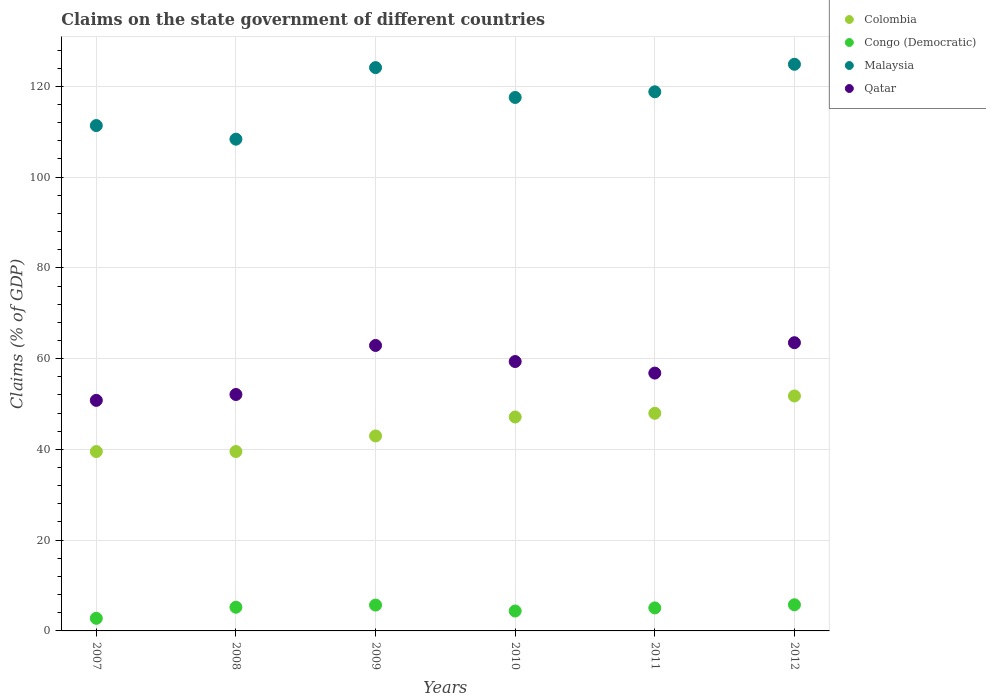Is the number of dotlines equal to the number of legend labels?
Offer a very short reply. Yes. What is the percentage of GDP claimed on the state government in Qatar in 2012?
Provide a short and direct response. 63.51. Across all years, what is the maximum percentage of GDP claimed on the state government in Congo (Democratic)?
Offer a very short reply. 5.76. Across all years, what is the minimum percentage of GDP claimed on the state government in Malaysia?
Offer a terse response. 108.35. What is the total percentage of GDP claimed on the state government in Congo (Democratic) in the graph?
Keep it short and to the point. 28.92. What is the difference between the percentage of GDP claimed on the state government in Qatar in 2008 and that in 2010?
Offer a very short reply. -7.26. What is the difference between the percentage of GDP claimed on the state government in Congo (Democratic) in 2010 and the percentage of GDP claimed on the state government in Malaysia in 2007?
Offer a very short reply. -106.96. What is the average percentage of GDP claimed on the state government in Malaysia per year?
Your response must be concise. 117.5. In the year 2010, what is the difference between the percentage of GDP claimed on the state government in Congo (Democratic) and percentage of GDP claimed on the state government in Malaysia?
Your answer should be very brief. -113.15. In how many years, is the percentage of GDP claimed on the state government in Qatar greater than 56 %?
Keep it short and to the point. 4. What is the ratio of the percentage of GDP claimed on the state government in Congo (Democratic) in 2010 to that in 2012?
Give a very brief answer. 0.76. Is the percentage of GDP claimed on the state government in Malaysia in 2007 less than that in 2010?
Ensure brevity in your answer.  Yes. Is the difference between the percentage of GDP claimed on the state government in Congo (Democratic) in 2007 and 2010 greater than the difference between the percentage of GDP claimed on the state government in Malaysia in 2007 and 2010?
Your response must be concise. Yes. What is the difference between the highest and the second highest percentage of GDP claimed on the state government in Qatar?
Your answer should be compact. 0.61. What is the difference between the highest and the lowest percentage of GDP claimed on the state government in Colombia?
Keep it short and to the point. 12.25. In how many years, is the percentage of GDP claimed on the state government in Qatar greater than the average percentage of GDP claimed on the state government in Qatar taken over all years?
Keep it short and to the point. 3. Is the sum of the percentage of GDP claimed on the state government in Congo (Democratic) in 2010 and 2012 greater than the maximum percentage of GDP claimed on the state government in Malaysia across all years?
Your response must be concise. No. Is it the case that in every year, the sum of the percentage of GDP claimed on the state government in Malaysia and percentage of GDP claimed on the state government in Colombia  is greater than the sum of percentage of GDP claimed on the state government in Congo (Democratic) and percentage of GDP claimed on the state government in Qatar?
Keep it short and to the point. No. Does the percentage of GDP claimed on the state government in Qatar monotonically increase over the years?
Your response must be concise. No. How many years are there in the graph?
Your response must be concise. 6. Are the values on the major ticks of Y-axis written in scientific E-notation?
Offer a terse response. No. Does the graph contain any zero values?
Give a very brief answer. No. Does the graph contain grids?
Provide a succinct answer. Yes. Where does the legend appear in the graph?
Your answer should be very brief. Top right. What is the title of the graph?
Provide a short and direct response. Claims on the state government of different countries. Does "Italy" appear as one of the legend labels in the graph?
Provide a succinct answer. No. What is the label or title of the Y-axis?
Your answer should be very brief. Claims (% of GDP). What is the Claims (% of GDP) in Colombia in 2007?
Offer a terse response. 39.53. What is the Claims (% of GDP) in Congo (Democratic) in 2007?
Your response must be concise. 2.78. What is the Claims (% of GDP) of Malaysia in 2007?
Give a very brief answer. 111.35. What is the Claims (% of GDP) in Qatar in 2007?
Keep it short and to the point. 50.8. What is the Claims (% of GDP) in Colombia in 2008?
Make the answer very short. 39.53. What is the Claims (% of GDP) of Congo (Democratic) in 2008?
Make the answer very short. 5.22. What is the Claims (% of GDP) in Malaysia in 2008?
Give a very brief answer. 108.35. What is the Claims (% of GDP) in Qatar in 2008?
Your answer should be very brief. 52.09. What is the Claims (% of GDP) in Colombia in 2009?
Provide a succinct answer. 42.96. What is the Claims (% of GDP) in Congo (Democratic) in 2009?
Your answer should be compact. 5.7. What is the Claims (% of GDP) of Malaysia in 2009?
Make the answer very short. 124.12. What is the Claims (% of GDP) in Qatar in 2009?
Provide a succinct answer. 62.9. What is the Claims (% of GDP) of Colombia in 2010?
Offer a very short reply. 47.14. What is the Claims (% of GDP) of Congo (Democratic) in 2010?
Your answer should be compact. 4.39. What is the Claims (% of GDP) in Malaysia in 2010?
Your answer should be very brief. 117.54. What is the Claims (% of GDP) of Qatar in 2010?
Offer a very short reply. 59.36. What is the Claims (% of GDP) of Colombia in 2011?
Your answer should be very brief. 47.96. What is the Claims (% of GDP) in Congo (Democratic) in 2011?
Provide a succinct answer. 5.07. What is the Claims (% of GDP) in Malaysia in 2011?
Give a very brief answer. 118.79. What is the Claims (% of GDP) of Qatar in 2011?
Your answer should be very brief. 56.81. What is the Claims (% of GDP) of Colombia in 2012?
Ensure brevity in your answer.  51.77. What is the Claims (% of GDP) in Congo (Democratic) in 2012?
Provide a succinct answer. 5.76. What is the Claims (% of GDP) of Malaysia in 2012?
Keep it short and to the point. 124.86. What is the Claims (% of GDP) in Qatar in 2012?
Provide a succinct answer. 63.51. Across all years, what is the maximum Claims (% of GDP) of Colombia?
Offer a very short reply. 51.77. Across all years, what is the maximum Claims (% of GDP) of Congo (Democratic)?
Ensure brevity in your answer.  5.76. Across all years, what is the maximum Claims (% of GDP) in Malaysia?
Offer a very short reply. 124.86. Across all years, what is the maximum Claims (% of GDP) of Qatar?
Offer a terse response. 63.51. Across all years, what is the minimum Claims (% of GDP) in Colombia?
Offer a terse response. 39.53. Across all years, what is the minimum Claims (% of GDP) of Congo (Democratic)?
Your answer should be very brief. 2.78. Across all years, what is the minimum Claims (% of GDP) in Malaysia?
Make the answer very short. 108.35. Across all years, what is the minimum Claims (% of GDP) in Qatar?
Make the answer very short. 50.8. What is the total Claims (% of GDP) of Colombia in the graph?
Provide a short and direct response. 268.89. What is the total Claims (% of GDP) of Congo (Democratic) in the graph?
Keep it short and to the point. 28.92. What is the total Claims (% of GDP) in Malaysia in the graph?
Give a very brief answer. 705.02. What is the total Claims (% of GDP) in Qatar in the graph?
Your answer should be very brief. 345.47. What is the difference between the Claims (% of GDP) of Colombia in 2007 and that in 2008?
Your response must be concise. -0.01. What is the difference between the Claims (% of GDP) in Congo (Democratic) in 2007 and that in 2008?
Your response must be concise. -2.44. What is the difference between the Claims (% of GDP) in Malaysia in 2007 and that in 2008?
Give a very brief answer. 3. What is the difference between the Claims (% of GDP) of Qatar in 2007 and that in 2008?
Offer a terse response. -1.3. What is the difference between the Claims (% of GDP) of Colombia in 2007 and that in 2009?
Your response must be concise. -3.44. What is the difference between the Claims (% of GDP) in Congo (Democratic) in 2007 and that in 2009?
Give a very brief answer. -2.92. What is the difference between the Claims (% of GDP) in Malaysia in 2007 and that in 2009?
Your response must be concise. -12.77. What is the difference between the Claims (% of GDP) of Qatar in 2007 and that in 2009?
Provide a short and direct response. -12.1. What is the difference between the Claims (% of GDP) in Colombia in 2007 and that in 2010?
Provide a short and direct response. -7.62. What is the difference between the Claims (% of GDP) in Congo (Democratic) in 2007 and that in 2010?
Provide a short and direct response. -1.61. What is the difference between the Claims (% of GDP) in Malaysia in 2007 and that in 2010?
Keep it short and to the point. -6.19. What is the difference between the Claims (% of GDP) of Qatar in 2007 and that in 2010?
Your answer should be compact. -8.56. What is the difference between the Claims (% of GDP) in Colombia in 2007 and that in 2011?
Keep it short and to the point. -8.43. What is the difference between the Claims (% of GDP) of Congo (Democratic) in 2007 and that in 2011?
Offer a very short reply. -2.3. What is the difference between the Claims (% of GDP) in Malaysia in 2007 and that in 2011?
Provide a succinct answer. -7.44. What is the difference between the Claims (% of GDP) in Qatar in 2007 and that in 2011?
Provide a short and direct response. -6.01. What is the difference between the Claims (% of GDP) in Colombia in 2007 and that in 2012?
Keep it short and to the point. -12.25. What is the difference between the Claims (% of GDP) in Congo (Democratic) in 2007 and that in 2012?
Make the answer very short. -2.99. What is the difference between the Claims (% of GDP) in Malaysia in 2007 and that in 2012?
Offer a very short reply. -13.5. What is the difference between the Claims (% of GDP) of Qatar in 2007 and that in 2012?
Your answer should be very brief. -12.71. What is the difference between the Claims (% of GDP) of Colombia in 2008 and that in 2009?
Your answer should be very brief. -3.43. What is the difference between the Claims (% of GDP) of Congo (Democratic) in 2008 and that in 2009?
Give a very brief answer. -0.48. What is the difference between the Claims (% of GDP) in Malaysia in 2008 and that in 2009?
Your answer should be very brief. -15.77. What is the difference between the Claims (% of GDP) of Qatar in 2008 and that in 2009?
Give a very brief answer. -10.81. What is the difference between the Claims (% of GDP) in Colombia in 2008 and that in 2010?
Provide a succinct answer. -7.61. What is the difference between the Claims (% of GDP) of Congo (Democratic) in 2008 and that in 2010?
Keep it short and to the point. 0.83. What is the difference between the Claims (% of GDP) in Malaysia in 2008 and that in 2010?
Provide a succinct answer. -9.19. What is the difference between the Claims (% of GDP) in Qatar in 2008 and that in 2010?
Offer a terse response. -7.26. What is the difference between the Claims (% of GDP) in Colombia in 2008 and that in 2011?
Give a very brief answer. -8.42. What is the difference between the Claims (% of GDP) in Congo (Democratic) in 2008 and that in 2011?
Offer a very short reply. 0.15. What is the difference between the Claims (% of GDP) in Malaysia in 2008 and that in 2011?
Your response must be concise. -10.44. What is the difference between the Claims (% of GDP) of Qatar in 2008 and that in 2011?
Ensure brevity in your answer.  -4.72. What is the difference between the Claims (% of GDP) of Colombia in 2008 and that in 2012?
Give a very brief answer. -12.24. What is the difference between the Claims (% of GDP) in Congo (Democratic) in 2008 and that in 2012?
Offer a terse response. -0.55. What is the difference between the Claims (% of GDP) in Malaysia in 2008 and that in 2012?
Your answer should be compact. -16.5. What is the difference between the Claims (% of GDP) of Qatar in 2008 and that in 2012?
Offer a very short reply. -11.41. What is the difference between the Claims (% of GDP) of Colombia in 2009 and that in 2010?
Give a very brief answer. -4.18. What is the difference between the Claims (% of GDP) in Congo (Democratic) in 2009 and that in 2010?
Make the answer very short. 1.31. What is the difference between the Claims (% of GDP) of Malaysia in 2009 and that in 2010?
Keep it short and to the point. 6.58. What is the difference between the Claims (% of GDP) of Qatar in 2009 and that in 2010?
Offer a very short reply. 3.54. What is the difference between the Claims (% of GDP) in Colombia in 2009 and that in 2011?
Your response must be concise. -4.99. What is the difference between the Claims (% of GDP) in Congo (Democratic) in 2009 and that in 2011?
Your answer should be very brief. 0.63. What is the difference between the Claims (% of GDP) in Malaysia in 2009 and that in 2011?
Your answer should be very brief. 5.33. What is the difference between the Claims (% of GDP) of Qatar in 2009 and that in 2011?
Ensure brevity in your answer.  6.09. What is the difference between the Claims (% of GDP) of Colombia in 2009 and that in 2012?
Your answer should be very brief. -8.81. What is the difference between the Claims (% of GDP) of Congo (Democratic) in 2009 and that in 2012?
Give a very brief answer. -0.07. What is the difference between the Claims (% of GDP) of Malaysia in 2009 and that in 2012?
Your response must be concise. -0.73. What is the difference between the Claims (% of GDP) of Qatar in 2009 and that in 2012?
Give a very brief answer. -0.61. What is the difference between the Claims (% of GDP) of Colombia in 2010 and that in 2011?
Provide a succinct answer. -0.81. What is the difference between the Claims (% of GDP) of Congo (Democratic) in 2010 and that in 2011?
Ensure brevity in your answer.  -0.68. What is the difference between the Claims (% of GDP) of Malaysia in 2010 and that in 2011?
Keep it short and to the point. -1.25. What is the difference between the Claims (% of GDP) in Qatar in 2010 and that in 2011?
Offer a terse response. 2.55. What is the difference between the Claims (% of GDP) in Colombia in 2010 and that in 2012?
Your answer should be compact. -4.63. What is the difference between the Claims (% of GDP) of Congo (Democratic) in 2010 and that in 2012?
Your answer should be compact. -1.37. What is the difference between the Claims (% of GDP) of Malaysia in 2010 and that in 2012?
Keep it short and to the point. -7.31. What is the difference between the Claims (% of GDP) in Qatar in 2010 and that in 2012?
Your response must be concise. -4.15. What is the difference between the Claims (% of GDP) of Colombia in 2011 and that in 2012?
Your answer should be compact. -3.82. What is the difference between the Claims (% of GDP) in Congo (Democratic) in 2011 and that in 2012?
Make the answer very short. -0.69. What is the difference between the Claims (% of GDP) of Malaysia in 2011 and that in 2012?
Ensure brevity in your answer.  -6.06. What is the difference between the Claims (% of GDP) in Qatar in 2011 and that in 2012?
Provide a succinct answer. -6.69. What is the difference between the Claims (% of GDP) in Colombia in 2007 and the Claims (% of GDP) in Congo (Democratic) in 2008?
Provide a short and direct response. 34.31. What is the difference between the Claims (% of GDP) of Colombia in 2007 and the Claims (% of GDP) of Malaysia in 2008?
Provide a short and direct response. -68.82. What is the difference between the Claims (% of GDP) in Colombia in 2007 and the Claims (% of GDP) in Qatar in 2008?
Offer a terse response. -12.57. What is the difference between the Claims (% of GDP) in Congo (Democratic) in 2007 and the Claims (% of GDP) in Malaysia in 2008?
Provide a succinct answer. -105.57. What is the difference between the Claims (% of GDP) of Congo (Democratic) in 2007 and the Claims (% of GDP) of Qatar in 2008?
Keep it short and to the point. -49.32. What is the difference between the Claims (% of GDP) of Malaysia in 2007 and the Claims (% of GDP) of Qatar in 2008?
Make the answer very short. 59.26. What is the difference between the Claims (% of GDP) of Colombia in 2007 and the Claims (% of GDP) of Congo (Democratic) in 2009?
Ensure brevity in your answer.  33.83. What is the difference between the Claims (% of GDP) of Colombia in 2007 and the Claims (% of GDP) of Malaysia in 2009?
Make the answer very short. -84.6. What is the difference between the Claims (% of GDP) of Colombia in 2007 and the Claims (% of GDP) of Qatar in 2009?
Make the answer very short. -23.37. What is the difference between the Claims (% of GDP) of Congo (Democratic) in 2007 and the Claims (% of GDP) of Malaysia in 2009?
Your answer should be very brief. -121.35. What is the difference between the Claims (% of GDP) in Congo (Democratic) in 2007 and the Claims (% of GDP) in Qatar in 2009?
Offer a very short reply. -60.12. What is the difference between the Claims (% of GDP) in Malaysia in 2007 and the Claims (% of GDP) in Qatar in 2009?
Your response must be concise. 48.45. What is the difference between the Claims (% of GDP) of Colombia in 2007 and the Claims (% of GDP) of Congo (Democratic) in 2010?
Offer a very short reply. 35.13. What is the difference between the Claims (% of GDP) of Colombia in 2007 and the Claims (% of GDP) of Malaysia in 2010?
Offer a very short reply. -78.02. What is the difference between the Claims (% of GDP) in Colombia in 2007 and the Claims (% of GDP) in Qatar in 2010?
Offer a very short reply. -19.83. What is the difference between the Claims (% of GDP) in Congo (Democratic) in 2007 and the Claims (% of GDP) in Malaysia in 2010?
Your answer should be very brief. -114.77. What is the difference between the Claims (% of GDP) of Congo (Democratic) in 2007 and the Claims (% of GDP) of Qatar in 2010?
Provide a succinct answer. -56.58. What is the difference between the Claims (% of GDP) of Malaysia in 2007 and the Claims (% of GDP) of Qatar in 2010?
Provide a short and direct response. 51.99. What is the difference between the Claims (% of GDP) of Colombia in 2007 and the Claims (% of GDP) of Congo (Democratic) in 2011?
Offer a very short reply. 34.45. What is the difference between the Claims (% of GDP) of Colombia in 2007 and the Claims (% of GDP) of Malaysia in 2011?
Make the answer very short. -79.27. What is the difference between the Claims (% of GDP) in Colombia in 2007 and the Claims (% of GDP) in Qatar in 2011?
Your answer should be compact. -17.29. What is the difference between the Claims (% of GDP) of Congo (Democratic) in 2007 and the Claims (% of GDP) of Malaysia in 2011?
Ensure brevity in your answer.  -116.02. What is the difference between the Claims (% of GDP) of Congo (Democratic) in 2007 and the Claims (% of GDP) of Qatar in 2011?
Give a very brief answer. -54.04. What is the difference between the Claims (% of GDP) of Malaysia in 2007 and the Claims (% of GDP) of Qatar in 2011?
Make the answer very short. 54.54. What is the difference between the Claims (% of GDP) in Colombia in 2007 and the Claims (% of GDP) in Congo (Democratic) in 2012?
Provide a short and direct response. 33.76. What is the difference between the Claims (% of GDP) of Colombia in 2007 and the Claims (% of GDP) of Malaysia in 2012?
Offer a terse response. -85.33. What is the difference between the Claims (% of GDP) in Colombia in 2007 and the Claims (% of GDP) in Qatar in 2012?
Keep it short and to the point. -23.98. What is the difference between the Claims (% of GDP) of Congo (Democratic) in 2007 and the Claims (% of GDP) of Malaysia in 2012?
Ensure brevity in your answer.  -122.08. What is the difference between the Claims (% of GDP) in Congo (Democratic) in 2007 and the Claims (% of GDP) in Qatar in 2012?
Give a very brief answer. -60.73. What is the difference between the Claims (% of GDP) in Malaysia in 2007 and the Claims (% of GDP) in Qatar in 2012?
Provide a short and direct response. 47.85. What is the difference between the Claims (% of GDP) of Colombia in 2008 and the Claims (% of GDP) of Congo (Democratic) in 2009?
Your response must be concise. 33.83. What is the difference between the Claims (% of GDP) of Colombia in 2008 and the Claims (% of GDP) of Malaysia in 2009?
Ensure brevity in your answer.  -84.59. What is the difference between the Claims (% of GDP) of Colombia in 2008 and the Claims (% of GDP) of Qatar in 2009?
Make the answer very short. -23.37. What is the difference between the Claims (% of GDP) in Congo (Democratic) in 2008 and the Claims (% of GDP) in Malaysia in 2009?
Provide a short and direct response. -118.9. What is the difference between the Claims (% of GDP) of Congo (Democratic) in 2008 and the Claims (% of GDP) of Qatar in 2009?
Provide a succinct answer. -57.68. What is the difference between the Claims (% of GDP) in Malaysia in 2008 and the Claims (% of GDP) in Qatar in 2009?
Provide a short and direct response. 45.45. What is the difference between the Claims (% of GDP) of Colombia in 2008 and the Claims (% of GDP) of Congo (Democratic) in 2010?
Provide a succinct answer. 35.14. What is the difference between the Claims (% of GDP) of Colombia in 2008 and the Claims (% of GDP) of Malaysia in 2010?
Provide a short and direct response. -78.01. What is the difference between the Claims (% of GDP) of Colombia in 2008 and the Claims (% of GDP) of Qatar in 2010?
Your answer should be very brief. -19.83. What is the difference between the Claims (% of GDP) of Congo (Democratic) in 2008 and the Claims (% of GDP) of Malaysia in 2010?
Provide a succinct answer. -112.33. What is the difference between the Claims (% of GDP) in Congo (Democratic) in 2008 and the Claims (% of GDP) in Qatar in 2010?
Offer a terse response. -54.14. What is the difference between the Claims (% of GDP) in Malaysia in 2008 and the Claims (% of GDP) in Qatar in 2010?
Provide a short and direct response. 48.99. What is the difference between the Claims (% of GDP) in Colombia in 2008 and the Claims (% of GDP) in Congo (Democratic) in 2011?
Give a very brief answer. 34.46. What is the difference between the Claims (% of GDP) of Colombia in 2008 and the Claims (% of GDP) of Malaysia in 2011?
Provide a succinct answer. -79.26. What is the difference between the Claims (% of GDP) in Colombia in 2008 and the Claims (% of GDP) in Qatar in 2011?
Offer a terse response. -17.28. What is the difference between the Claims (% of GDP) in Congo (Democratic) in 2008 and the Claims (% of GDP) in Malaysia in 2011?
Ensure brevity in your answer.  -113.57. What is the difference between the Claims (% of GDP) of Congo (Democratic) in 2008 and the Claims (% of GDP) of Qatar in 2011?
Your response must be concise. -51.59. What is the difference between the Claims (% of GDP) in Malaysia in 2008 and the Claims (% of GDP) in Qatar in 2011?
Make the answer very short. 51.54. What is the difference between the Claims (% of GDP) of Colombia in 2008 and the Claims (% of GDP) of Congo (Democratic) in 2012?
Your response must be concise. 33.77. What is the difference between the Claims (% of GDP) of Colombia in 2008 and the Claims (% of GDP) of Malaysia in 2012?
Make the answer very short. -85.32. What is the difference between the Claims (% of GDP) in Colombia in 2008 and the Claims (% of GDP) in Qatar in 2012?
Your answer should be very brief. -23.98. What is the difference between the Claims (% of GDP) in Congo (Democratic) in 2008 and the Claims (% of GDP) in Malaysia in 2012?
Offer a terse response. -119.64. What is the difference between the Claims (% of GDP) in Congo (Democratic) in 2008 and the Claims (% of GDP) in Qatar in 2012?
Your response must be concise. -58.29. What is the difference between the Claims (% of GDP) of Malaysia in 2008 and the Claims (% of GDP) of Qatar in 2012?
Offer a very short reply. 44.84. What is the difference between the Claims (% of GDP) of Colombia in 2009 and the Claims (% of GDP) of Congo (Democratic) in 2010?
Offer a terse response. 38.57. What is the difference between the Claims (% of GDP) in Colombia in 2009 and the Claims (% of GDP) in Malaysia in 2010?
Provide a short and direct response. -74.58. What is the difference between the Claims (% of GDP) of Colombia in 2009 and the Claims (% of GDP) of Qatar in 2010?
Ensure brevity in your answer.  -16.4. What is the difference between the Claims (% of GDP) in Congo (Democratic) in 2009 and the Claims (% of GDP) in Malaysia in 2010?
Your answer should be compact. -111.85. What is the difference between the Claims (% of GDP) of Congo (Democratic) in 2009 and the Claims (% of GDP) of Qatar in 2010?
Keep it short and to the point. -53.66. What is the difference between the Claims (% of GDP) of Malaysia in 2009 and the Claims (% of GDP) of Qatar in 2010?
Ensure brevity in your answer.  64.76. What is the difference between the Claims (% of GDP) in Colombia in 2009 and the Claims (% of GDP) in Congo (Democratic) in 2011?
Provide a short and direct response. 37.89. What is the difference between the Claims (% of GDP) in Colombia in 2009 and the Claims (% of GDP) in Malaysia in 2011?
Keep it short and to the point. -75.83. What is the difference between the Claims (% of GDP) in Colombia in 2009 and the Claims (% of GDP) in Qatar in 2011?
Your answer should be very brief. -13.85. What is the difference between the Claims (% of GDP) of Congo (Democratic) in 2009 and the Claims (% of GDP) of Malaysia in 2011?
Ensure brevity in your answer.  -113.09. What is the difference between the Claims (% of GDP) in Congo (Democratic) in 2009 and the Claims (% of GDP) in Qatar in 2011?
Make the answer very short. -51.11. What is the difference between the Claims (% of GDP) in Malaysia in 2009 and the Claims (% of GDP) in Qatar in 2011?
Offer a very short reply. 67.31. What is the difference between the Claims (% of GDP) in Colombia in 2009 and the Claims (% of GDP) in Congo (Democratic) in 2012?
Ensure brevity in your answer.  37.2. What is the difference between the Claims (% of GDP) of Colombia in 2009 and the Claims (% of GDP) of Malaysia in 2012?
Make the answer very short. -81.89. What is the difference between the Claims (% of GDP) in Colombia in 2009 and the Claims (% of GDP) in Qatar in 2012?
Give a very brief answer. -20.54. What is the difference between the Claims (% of GDP) in Congo (Democratic) in 2009 and the Claims (% of GDP) in Malaysia in 2012?
Your answer should be compact. -119.16. What is the difference between the Claims (% of GDP) in Congo (Democratic) in 2009 and the Claims (% of GDP) in Qatar in 2012?
Keep it short and to the point. -57.81. What is the difference between the Claims (% of GDP) of Malaysia in 2009 and the Claims (% of GDP) of Qatar in 2012?
Provide a short and direct response. 60.62. What is the difference between the Claims (% of GDP) in Colombia in 2010 and the Claims (% of GDP) in Congo (Democratic) in 2011?
Provide a succinct answer. 42.07. What is the difference between the Claims (% of GDP) of Colombia in 2010 and the Claims (% of GDP) of Malaysia in 2011?
Give a very brief answer. -71.65. What is the difference between the Claims (% of GDP) in Colombia in 2010 and the Claims (% of GDP) in Qatar in 2011?
Offer a very short reply. -9.67. What is the difference between the Claims (% of GDP) in Congo (Democratic) in 2010 and the Claims (% of GDP) in Malaysia in 2011?
Offer a very short reply. -114.4. What is the difference between the Claims (% of GDP) in Congo (Democratic) in 2010 and the Claims (% of GDP) in Qatar in 2011?
Offer a terse response. -52.42. What is the difference between the Claims (% of GDP) in Malaysia in 2010 and the Claims (% of GDP) in Qatar in 2011?
Your response must be concise. 60.73. What is the difference between the Claims (% of GDP) of Colombia in 2010 and the Claims (% of GDP) of Congo (Democratic) in 2012?
Your answer should be very brief. 41.38. What is the difference between the Claims (% of GDP) in Colombia in 2010 and the Claims (% of GDP) in Malaysia in 2012?
Offer a terse response. -77.71. What is the difference between the Claims (% of GDP) of Colombia in 2010 and the Claims (% of GDP) of Qatar in 2012?
Your answer should be compact. -16.36. What is the difference between the Claims (% of GDP) of Congo (Democratic) in 2010 and the Claims (% of GDP) of Malaysia in 2012?
Make the answer very short. -120.46. What is the difference between the Claims (% of GDP) of Congo (Democratic) in 2010 and the Claims (% of GDP) of Qatar in 2012?
Offer a terse response. -59.12. What is the difference between the Claims (% of GDP) in Malaysia in 2010 and the Claims (% of GDP) in Qatar in 2012?
Offer a very short reply. 54.04. What is the difference between the Claims (% of GDP) in Colombia in 2011 and the Claims (% of GDP) in Congo (Democratic) in 2012?
Make the answer very short. 42.19. What is the difference between the Claims (% of GDP) of Colombia in 2011 and the Claims (% of GDP) of Malaysia in 2012?
Offer a very short reply. -76.9. What is the difference between the Claims (% of GDP) of Colombia in 2011 and the Claims (% of GDP) of Qatar in 2012?
Ensure brevity in your answer.  -15.55. What is the difference between the Claims (% of GDP) of Congo (Democratic) in 2011 and the Claims (% of GDP) of Malaysia in 2012?
Give a very brief answer. -119.78. What is the difference between the Claims (% of GDP) of Congo (Democratic) in 2011 and the Claims (% of GDP) of Qatar in 2012?
Provide a succinct answer. -58.44. What is the difference between the Claims (% of GDP) in Malaysia in 2011 and the Claims (% of GDP) in Qatar in 2012?
Provide a short and direct response. 55.29. What is the average Claims (% of GDP) in Colombia per year?
Ensure brevity in your answer.  44.82. What is the average Claims (% of GDP) of Congo (Democratic) per year?
Provide a succinct answer. 4.82. What is the average Claims (% of GDP) of Malaysia per year?
Give a very brief answer. 117.5. What is the average Claims (% of GDP) in Qatar per year?
Ensure brevity in your answer.  57.58. In the year 2007, what is the difference between the Claims (% of GDP) in Colombia and Claims (% of GDP) in Congo (Democratic)?
Your response must be concise. 36.75. In the year 2007, what is the difference between the Claims (% of GDP) of Colombia and Claims (% of GDP) of Malaysia?
Provide a short and direct response. -71.83. In the year 2007, what is the difference between the Claims (% of GDP) of Colombia and Claims (% of GDP) of Qatar?
Give a very brief answer. -11.27. In the year 2007, what is the difference between the Claims (% of GDP) of Congo (Democratic) and Claims (% of GDP) of Malaysia?
Give a very brief answer. -108.58. In the year 2007, what is the difference between the Claims (% of GDP) in Congo (Democratic) and Claims (% of GDP) in Qatar?
Keep it short and to the point. -48.02. In the year 2007, what is the difference between the Claims (% of GDP) in Malaysia and Claims (% of GDP) in Qatar?
Your answer should be compact. 60.56. In the year 2008, what is the difference between the Claims (% of GDP) of Colombia and Claims (% of GDP) of Congo (Democratic)?
Make the answer very short. 34.31. In the year 2008, what is the difference between the Claims (% of GDP) of Colombia and Claims (% of GDP) of Malaysia?
Offer a terse response. -68.82. In the year 2008, what is the difference between the Claims (% of GDP) in Colombia and Claims (% of GDP) in Qatar?
Your response must be concise. -12.56. In the year 2008, what is the difference between the Claims (% of GDP) in Congo (Democratic) and Claims (% of GDP) in Malaysia?
Your answer should be very brief. -103.13. In the year 2008, what is the difference between the Claims (% of GDP) of Congo (Democratic) and Claims (% of GDP) of Qatar?
Make the answer very short. -46.88. In the year 2008, what is the difference between the Claims (% of GDP) of Malaysia and Claims (% of GDP) of Qatar?
Ensure brevity in your answer.  56.26. In the year 2009, what is the difference between the Claims (% of GDP) in Colombia and Claims (% of GDP) in Congo (Democratic)?
Your answer should be very brief. 37.26. In the year 2009, what is the difference between the Claims (% of GDP) in Colombia and Claims (% of GDP) in Malaysia?
Keep it short and to the point. -81.16. In the year 2009, what is the difference between the Claims (% of GDP) of Colombia and Claims (% of GDP) of Qatar?
Provide a short and direct response. -19.94. In the year 2009, what is the difference between the Claims (% of GDP) of Congo (Democratic) and Claims (% of GDP) of Malaysia?
Offer a terse response. -118.43. In the year 2009, what is the difference between the Claims (% of GDP) in Congo (Democratic) and Claims (% of GDP) in Qatar?
Provide a succinct answer. -57.2. In the year 2009, what is the difference between the Claims (% of GDP) of Malaysia and Claims (% of GDP) of Qatar?
Your response must be concise. 61.22. In the year 2010, what is the difference between the Claims (% of GDP) of Colombia and Claims (% of GDP) of Congo (Democratic)?
Provide a short and direct response. 42.75. In the year 2010, what is the difference between the Claims (% of GDP) of Colombia and Claims (% of GDP) of Malaysia?
Provide a succinct answer. -70.4. In the year 2010, what is the difference between the Claims (% of GDP) in Colombia and Claims (% of GDP) in Qatar?
Provide a succinct answer. -12.21. In the year 2010, what is the difference between the Claims (% of GDP) of Congo (Democratic) and Claims (% of GDP) of Malaysia?
Your response must be concise. -113.15. In the year 2010, what is the difference between the Claims (% of GDP) in Congo (Democratic) and Claims (% of GDP) in Qatar?
Provide a short and direct response. -54.97. In the year 2010, what is the difference between the Claims (% of GDP) of Malaysia and Claims (% of GDP) of Qatar?
Your response must be concise. 58.18. In the year 2011, what is the difference between the Claims (% of GDP) in Colombia and Claims (% of GDP) in Congo (Democratic)?
Give a very brief answer. 42.88. In the year 2011, what is the difference between the Claims (% of GDP) of Colombia and Claims (% of GDP) of Malaysia?
Your answer should be compact. -70.84. In the year 2011, what is the difference between the Claims (% of GDP) of Colombia and Claims (% of GDP) of Qatar?
Offer a very short reply. -8.86. In the year 2011, what is the difference between the Claims (% of GDP) of Congo (Democratic) and Claims (% of GDP) of Malaysia?
Offer a very short reply. -113.72. In the year 2011, what is the difference between the Claims (% of GDP) in Congo (Democratic) and Claims (% of GDP) in Qatar?
Offer a very short reply. -51.74. In the year 2011, what is the difference between the Claims (% of GDP) in Malaysia and Claims (% of GDP) in Qatar?
Provide a succinct answer. 61.98. In the year 2012, what is the difference between the Claims (% of GDP) in Colombia and Claims (% of GDP) in Congo (Democratic)?
Your answer should be very brief. 46.01. In the year 2012, what is the difference between the Claims (% of GDP) in Colombia and Claims (% of GDP) in Malaysia?
Your response must be concise. -73.08. In the year 2012, what is the difference between the Claims (% of GDP) of Colombia and Claims (% of GDP) of Qatar?
Ensure brevity in your answer.  -11.73. In the year 2012, what is the difference between the Claims (% of GDP) in Congo (Democratic) and Claims (% of GDP) in Malaysia?
Your response must be concise. -119.09. In the year 2012, what is the difference between the Claims (% of GDP) of Congo (Democratic) and Claims (% of GDP) of Qatar?
Provide a succinct answer. -57.74. In the year 2012, what is the difference between the Claims (% of GDP) of Malaysia and Claims (% of GDP) of Qatar?
Keep it short and to the point. 61.35. What is the ratio of the Claims (% of GDP) of Congo (Democratic) in 2007 to that in 2008?
Your answer should be very brief. 0.53. What is the ratio of the Claims (% of GDP) in Malaysia in 2007 to that in 2008?
Give a very brief answer. 1.03. What is the ratio of the Claims (% of GDP) in Qatar in 2007 to that in 2008?
Your answer should be compact. 0.98. What is the ratio of the Claims (% of GDP) in Colombia in 2007 to that in 2009?
Your response must be concise. 0.92. What is the ratio of the Claims (% of GDP) in Congo (Democratic) in 2007 to that in 2009?
Offer a terse response. 0.49. What is the ratio of the Claims (% of GDP) of Malaysia in 2007 to that in 2009?
Your answer should be very brief. 0.9. What is the ratio of the Claims (% of GDP) in Qatar in 2007 to that in 2009?
Offer a terse response. 0.81. What is the ratio of the Claims (% of GDP) of Colombia in 2007 to that in 2010?
Your answer should be very brief. 0.84. What is the ratio of the Claims (% of GDP) of Congo (Democratic) in 2007 to that in 2010?
Your response must be concise. 0.63. What is the ratio of the Claims (% of GDP) of Malaysia in 2007 to that in 2010?
Give a very brief answer. 0.95. What is the ratio of the Claims (% of GDP) of Qatar in 2007 to that in 2010?
Make the answer very short. 0.86. What is the ratio of the Claims (% of GDP) in Colombia in 2007 to that in 2011?
Your answer should be very brief. 0.82. What is the ratio of the Claims (% of GDP) in Congo (Democratic) in 2007 to that in 2011?
Give a very brief answer. 0.55. What is the ratio of the Claims (% of GDP) in Malaysia in 2007 to that in 2011?
Your answer should be compact. 0.94. What is the ratio of the Claims (% of GDP) in Qatar in 2007 to that in 2011?
Provide a succinct answer. 0.89. What is the ratio of the Claims (% of GDP) of Colombia in 2007 to that in 2012?
Provide a succinct answer. 0.76. What is the ratio of the Claims (% of GDP) of Congo (Democratic) in 2007 to that in 2012?
Offer a terse response. 0.48. What is the ratio of the Claims (% of GDP) in Malaysia in 2007 to that in 2012?
Keep it short and to the point. 0.89. What is the ratio of the Claims (% of GDP) in Qatar in 2007 to that in 2012?
Your answer should be compact. 0.8. What is the ratio of the Claims (% of GDP) in Colombia in 2008 to that in 2009?
Keep it short and to the point. 0.92. What is the ratio of the Claims (% of GDP) in Congo (Democratic) in 2008 to that in 2009?
Keep it short and to the point. 0.92. What is the ratio of the Claims (% of GDP) of Malaysia in 2008 to that in 2009?
Provide a succinct answer. 0.87. What is the ratio of the Claims (% of GDP) in Qatar in 2008 to that in 2009?
Provide a short and direct response. 0.83. What is the ratio of the Claims (% of GDP) of Colombia in 2008 to that in 2010?
Provide a succinct answer. 0.84. What is the ratio of the Claims (% of GDP) of Congo (Democratic) in 2008 to that in 2010?
Your answer should be very brief. 1.19. What is the ratio of the Claims (% of GDP) of Malaysia in 2008 to that in 2010?
Offer a terse response. 0.92. What is the ratio of the Claims (% of GDP) of Qatar in 2008 to that in 2010?
Provide a succinct answer. 0.88. What is the ratio of the Claims (% of GDP) in Colombia in 2008 to that in 2011?
Ensure brevity in your answer.  0.82. What is the ratio of the Claims (% of GDP) in Congo (Democratic) in 2008 to that in 2011?
Your answer should be compact. 1.03. What is the ratio of the Claims (% of GDP) of Malaysia in 2008 to that in 2011?
Provide a succinct answer. 0.91. What is the ratio of the Claims (% of GDP) in Qatar in 2008 to that in 2011?
Make the answer very short. 0.92. What is the ratio of the Claims (% of GDP) in Colombia in 2008 to that in 2012?
Give a very brief answer. 0.76. What is the ratio of the Claims (% of GDP) in Congo (Democratic) in 2008 to that in 2012?
Your response must be concise. 0.91. What is the ratio of the Claims (% of GDP) in Malaysia in 2008 to that in 2012?
Keep it short and to the point. 0.87. What is the ratio of the Claims (% of GDP) in Qatar in 2008 to that in 2012?
Your response must be concise. 0.82. What is the ratio of the Claims (% of GDP) in Colombia in 2009 to that in 2010?
Your answer should be compact. 0.91. What is the ratio of the Claims (% of GDP) of Congo (Democratic) in 2009 to that in 2010?
Provide a short and direct response. 1.3. What is the ratio of the Claims (% of GDP) of Malaysia in 2009 to that in 2010?
Make the answer very short. 1.06. What is the ratio of the Claims (% of GDP) of Qatar in 2009 to that in 2010?
Give a very brief answer. 1.06. What is the ratio of the Claims (% of GDP) in Colombia in 2009 to that in 2011?
Provide a short and direct response. 0.9. What is the ratio of the Claims (% of GDP) in Congo (Democratic) in 2009 to that in 2011?
Your response must be concise. 1.12. What is the ratio of the Claims (% of GDP) of Malaysia in 2009 to that in 2011?
Keep it short and to the point. 1.04. What is the ratio of the Claims (% of GDP) of Qatar in 2009 to that in 2011?
Offer a terse response. 1.11. What is the ratio of the Claims (% of GDP) in Colombia in 2009 to that in 2012?
Your answer should be very brief. 0.83. What is the ratio of the Claims (% of GDP) of Qatar in 2009 to that in 2012?
Give a very brief answer. 0.99. What is the ratio of the Claims (% of GDP) in Colombia in 2010 to that in 2011?
Your answer should be compact. 0.98. What is the ratio of the Claims (% of GDP) of Congo (Democratic) in 2010 to that in 2011?
Your response must be concise. 0.87. What is the ratio of the Claims (% of GDP) in Malaysia in 2010 to that in 2011?
Offer a very short reply. 0.99. What is the ratio of the Claims (% of GDP) of Qatar in 2010 to that in 2011?
Your response must be concise. 1.04. What is the ratio of the Claims (% of GDP) of Colombia in 2010 to that in 2012?
Your response must be concise. 0.91. What is the ratio of the Claims (% of GDP) of Congo (Democratic) in 2010 to that in 2012?
Offer a very short reply. 0.76. What is the ratio of the Claims (% of GDP) of Malaysia in 2010 to that in 2012?
Provide a short and direct response. 0.94. What is the ratio of the Claims (% of GDP) of Qatar in 2010 to that in 2012?
Your answer should be very brief. 0.93. What is the ratio of the Claims (% of GDP) of Colombia in 2011 to that in 2012?
Provide a succinct answer. 0.93. What is the ratio of the Claims (% of GDP) of Congo (Democratic) in 2011 to that in 2012?
Your response must be concise. 0.88. What is the ratio of the Claims (% of GDP) of Malaysia in 2011 to that in 2012?
Your answer should be very brief. 0.95. What is the ratio of the Claims (% of GDP) in Qatar in 2011 to that in 2012?
Offer a very short reply. 0.89. What is the difference between the highest and the second highest Claims (% of GDP) of Colombia?
Ensure brevity in your answer.  3.82. What is the difference between the highest and the second highest Claims (% of GDP) in Congo (Democratic)?
Offer a very short reply. 0.07. What is the difference between the highest and the second highest Claims (% of GDP) in Malaysia?
Keep it short and to the point. 0.73. What is the difference between the highest and the second highest Claims (% of GDP) of Qatar?
Provide a succinct answer. 0.61. What is the difference between the highest and the lowest Claims (% of GDP) of Colombia?
Your response must be concise. 12.25. What is the difference between the highest and the lowest Claims (% of GDP) of Congo (Democratic)?
Provide a succinct answer. 2.99. What is the difference between the highest and the lowest Claims (% of GDP) of Malaysia?
Your answer should be compact. 16.5. What is the difference between the highest and the lowest Claims (% of GDP) in Qatar?
Your response must be concise. 12.71. 